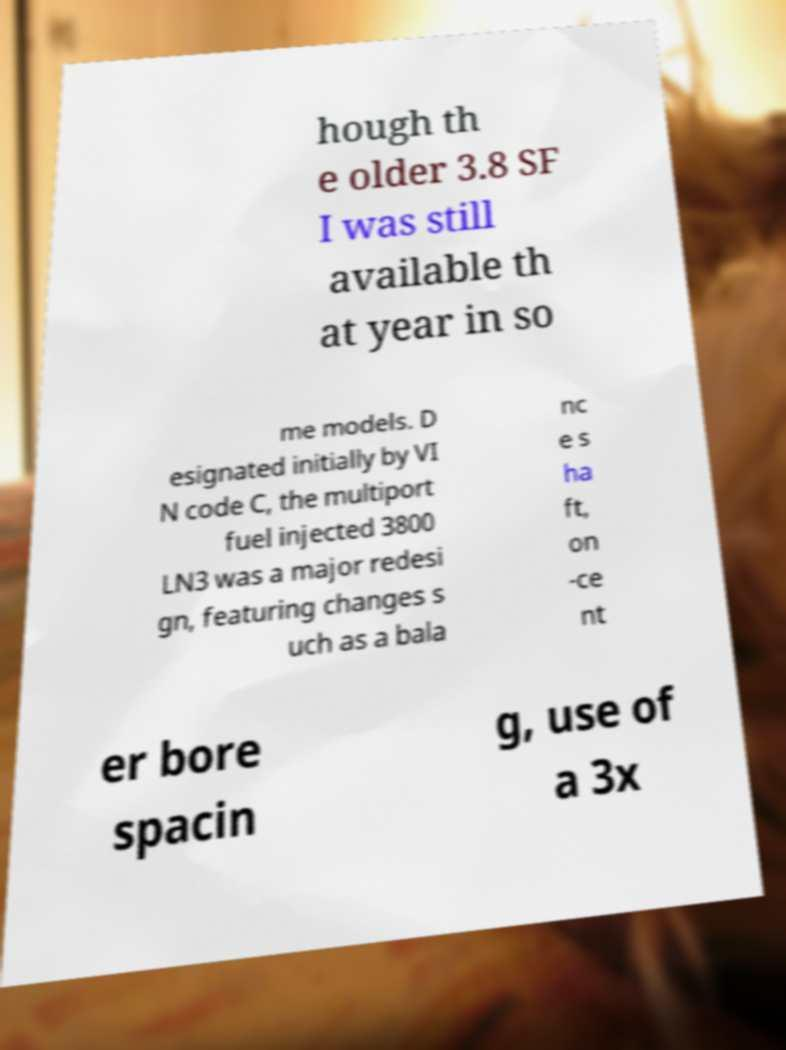There's text embedded in this image that I need extracted. Can you transcribe it verbatim? hough th e older 3.8 SF I was still available th at year in so me models. D esignated initially by VI N code C, the multiport fuel injected 3800 LN3 was a major redesi gn, featuring changes s uch as a bala nc e s ha ft, on -ce nt er bore spacin g, use of a 3x 